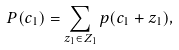<formula> <loc_0><loc_0><loc_500><loc_500>P ( c _ { 1 } ) = \sum _ { z _ { 1 } \in Z _ { 1 } } p ( c _ { 1 } + z _ { 1 } ) ,</formula> 